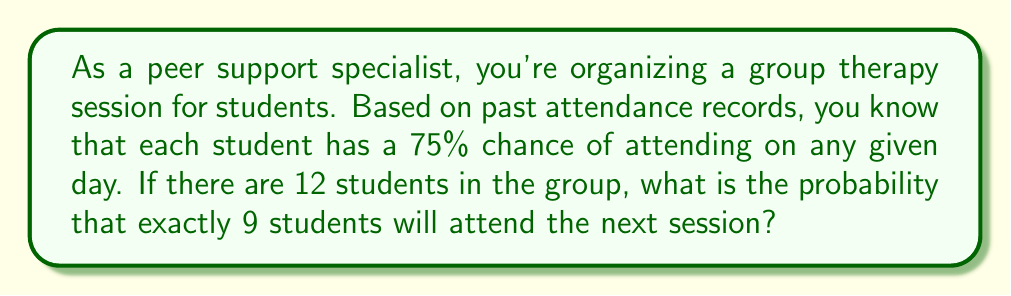What is the answer to this math problem? To solve this problem, we'll use the binomial probability formula, as this is a situation with a fixed number of independent trials (students), each with the same probability of success (attending).

The binomial probability formula is:

$$P(X = k) = \binom{n}{k} p^k (1-p)^{n-k}$$

Where:
$n$ = total number of trials (students) = 12
$k$ = number of successes (students attending) = 9
$p$ = probability of success (attending) = 0.75

Step 1: Calculate the binomial coefficient $\binom{n}{k}$
$$\binom{12}{9} = \frac{12!}{9!(12-9)!} = \frac{12!}{9!3!} = 220$$

Step 2: Calculate $p^k$
$$0.75^9 \approx 0.0751$$

Step 3: Calculate $(1-p)^{n-k}$
$$(1-0.75)^{12-9} = 0.25^3 = 0.015625$$

Step 4: Multiply the results from steps 1, 2, and 3
$$220 \times 0.0751 \times 0.015625 \approx 0.2583$$

Therefore, the probability of exactly 9 students attending is approximately 0.2583 or 25.83%.
Answer: The probability that exactly 9 out of 12 students will attend the next group therapy session is approximately 0.2583 or 25.83%. 